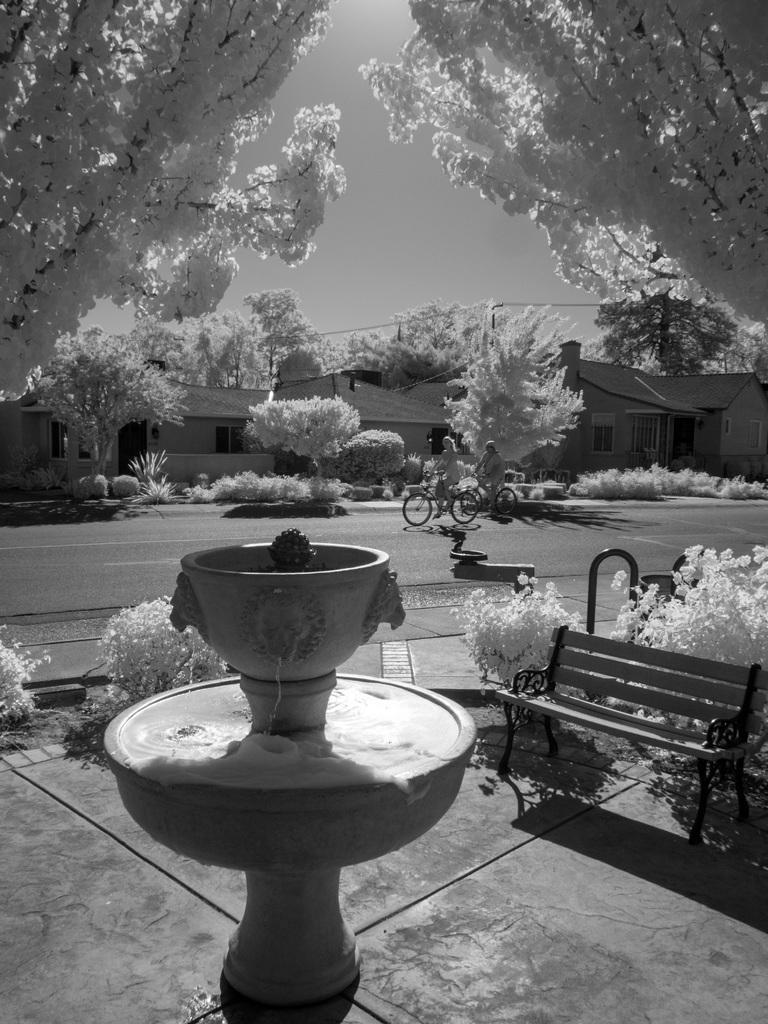Please provide a concise description of this image. in this image there is a pot, plant , bench and back ground there bicycle , building ,sky , tree. 